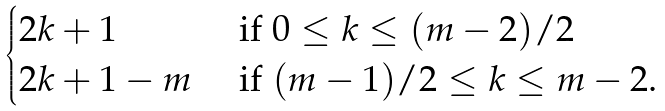<formula> <loc_0><loc_0><loc_500><loc_500>\begin{cases} 2 k + 1 & \text {  if } 0 \leq k \leq ( m - 2 ) / 2 \\ 2 k + 1 - m & \text { if } ( m - 1 ) / 2 \leq k \leq m - 2 . \end{cases}</formula> 